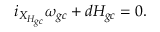<formula> <loc_0><loc_0><loc_500><loc_500>i _ { X _ { H _ { g c } } } \omega _ { g c } + d H _ { g c } = 0 .</formula> 